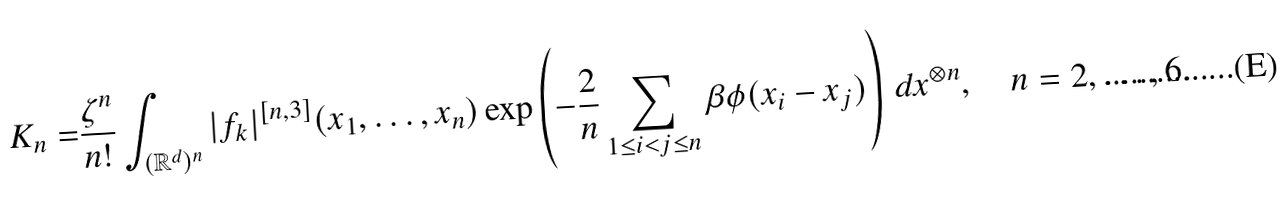<formula> <loc_0><loc_0><loc_500><loc_500>K _ { n } = & \frac { \zeta ^ { n } } { n ! } \int _ { ( { \mathbb { R } } ^ { d } ) ^ { n } } | f _ { k } | ^ { [ n , 3 ] } ( x _ { 1 } , \dots , x _ { n } ) \exp \left ( - \frac { 2 } { n } \sum _ { 1 \leq i < j \leq n } \beta \phi ( x _ { i } - x _ { j } ) \right ) \, d x ^ { \otimes n } , \quad n = 2 , \dots , 6 .</formula> 